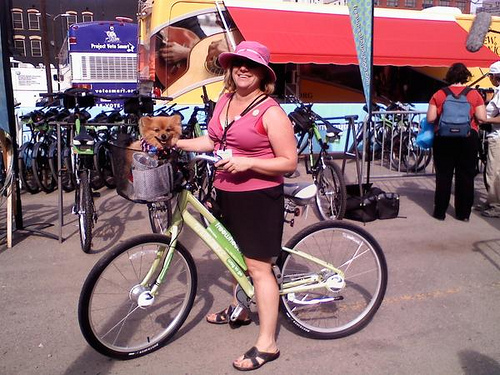<image>Does the person have tie or velcro shoes? The person does not have either tie or velcro shoes. Does the person have tie or velcro shoes? It is unanswerable whether the person has tie or velcro shoes. 